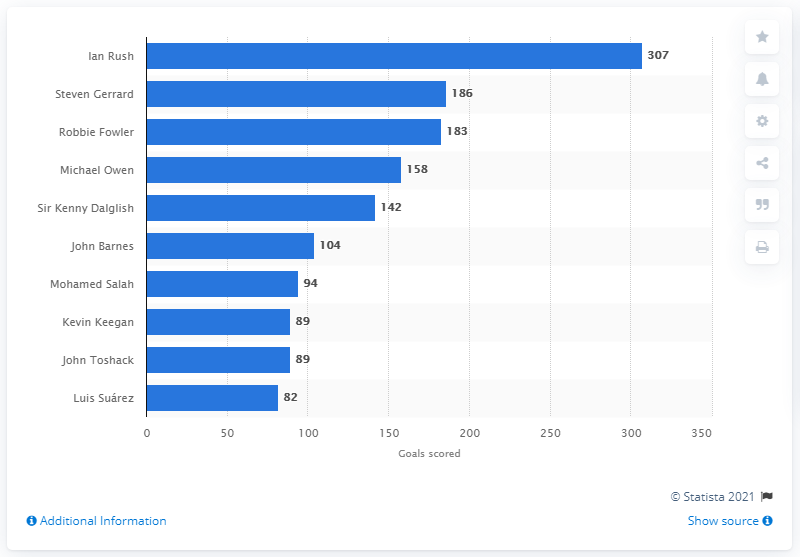Mention a couple of crucial points in this snapshot. As of July 2020, Steven Gerrard was the leading goal scorer for Liverpool FC. As of July 2020, Ian Rush had scored a total of 307 goals for Liverpool FC. 